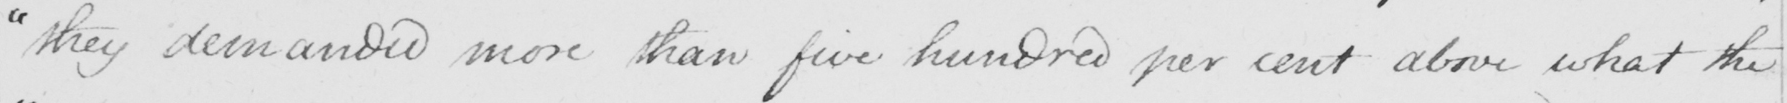Can you read and transcribe this handwriting? " they demanded more than five hundred per cent above what the 